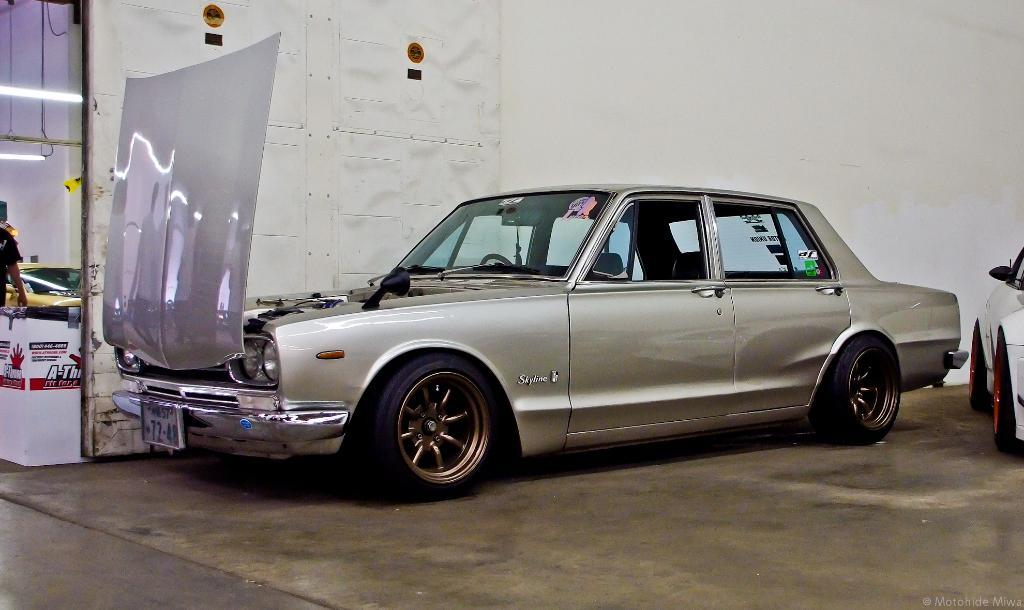What type of vehicle is in the image? There is a silver car in the image. Where is the car located? The car is parked in a shed. Which part of the car is visible in the image? The bonnet door of the car is visible. What can be seen in the background of the image? There is a white color wall in the background of the image. What type of bottle is being used to spy on the car in the image? There is no bottle or spying activity present in the image. 